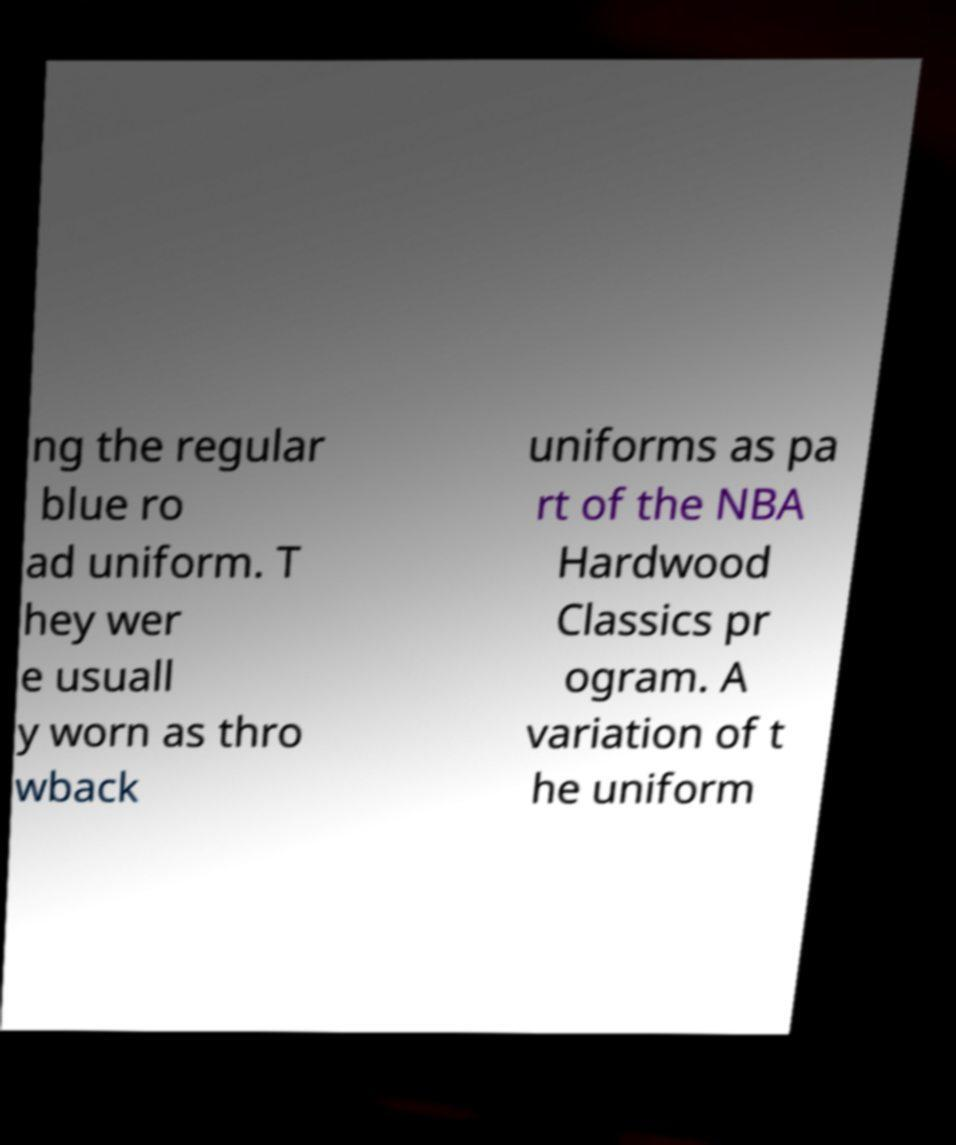Can you read and provide the text displayed in the image?This photo seems to have some interesting text. Can you extract and type it out for me? ng the regular blue ro ad uniform. T hey wer e usuall y worn as thro wback uniforms as pa rt of the NBA Hardwood Classics pr ogram. A variation of t he uniform 